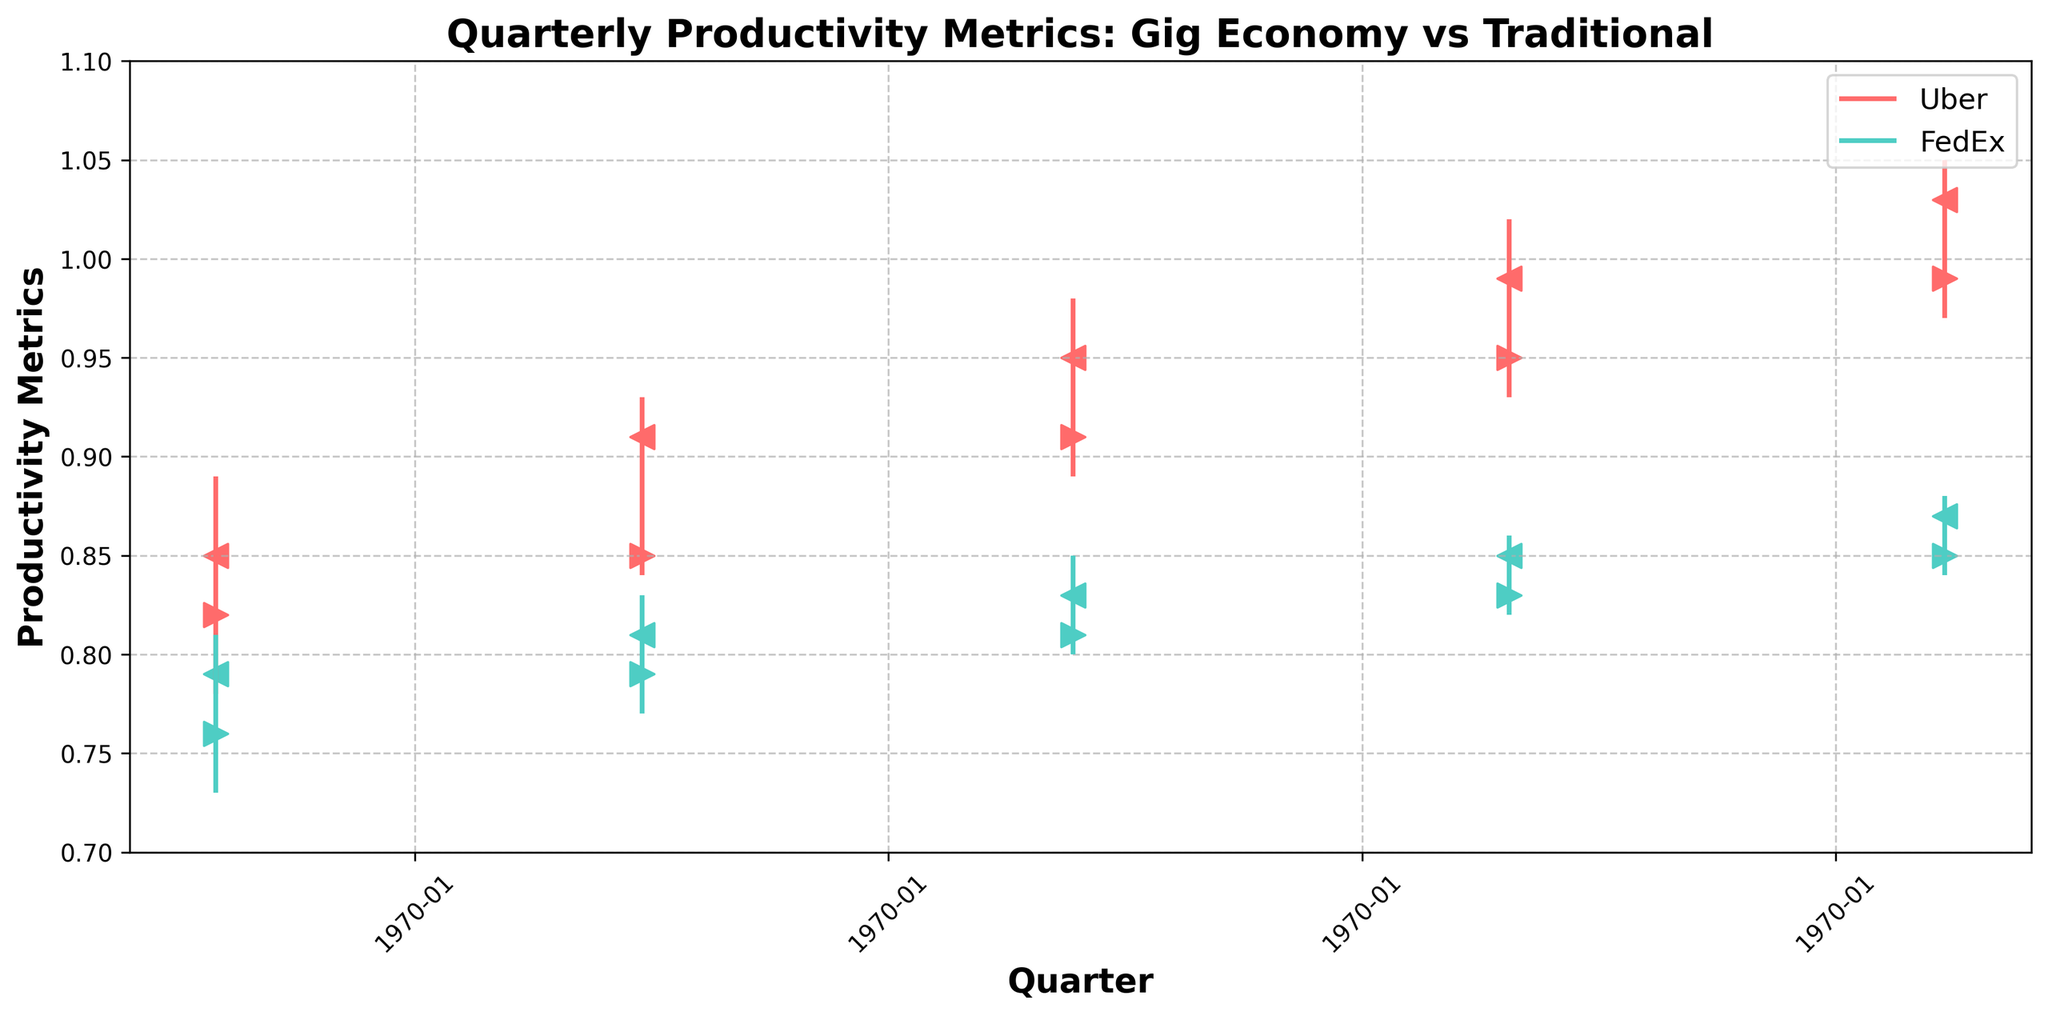What is the title of the chart? The title of the chart is displayed at the top center of the chart. It reads "Quarterly Productivity Metrics: Gig Economy vs Traditional".
Answer: Quarterly Productivity Metrics: Gig Economy vs Traditional How many companies are compared in the chart? The chart uses distinct colors for each company and there are two companies compared, identified in the legend as Uber and FedEx.
Answer: Two What is the highest productivity metric value reached by Uber, and in which quarter does it occur? Uber's highest metric value is represented by the highest vertical line for Uber, which reaches 1.05. This occurs in Q1 2024.
Answer: 1.05 in Q1 2024 Which company has a more substantial increase in the productivity metric from Q1 2023 to Q4 2023? Determine the difference in productivity metrics between Q4 2023 and Q1 2023 for each company. Uber goes from 0.85 (Q1 2023 Close) to 0.99 (Q4 2023 Close), a difference of 0.14. FedEx goes from 0.79 (Q1 2023 Close) to 0.85 (Q4 2023 Close), a difference of 0.06. Uber shows a more substantial increase.
Answer: Uber What is the overall trend in Uber's productivity metrics from Q1 2023 to Q1 2024? Analyze Uber's Close values across each quarter: 0.85 (Q1 2023), 0.91 (Q2 2023), 0.95 (Q3 2023), 0.99 (Q4 2023), 1.03 (Q1 2024). The values consistently increase, indicating an upward trend.
Answer: Upward trend What is the median productivity metric value of FedEx across all quarters? List FedEx's Close values: 0.79, 0.81, 0.83, 0.85, 0.87. Sorting these gives 0.79, 0.81, 0.83, 0.85, 0.87, and the median is the middle value, 0.83.
Answer: 0.83 Which company had greater volatility in productivity metrics in Q4 2023, based on the High-Low spread? Calculate the High-Low spread for both companies in Q4 2023. Uber's spread is 1.02 - 0.93 = 0.09 and FedEx's spread is 0.86 - 0.82 = 0.04. Uber has greater volatility.
Answer: Uber In which quarter did FedEx have the smallest difference between Open and Close values? Look at the Open and Close values for FedEx in each quarter: Q1 2023 (0.76, 0.79), Q2 2023 (0.79, 0.81), Q3 2023 (0.81, 0.83), Q4 2023 (0.83, 0.85), Q1 2024 (0.85, 0.87). The smallest difference is in Q2 2023 (0.81 - 0.79 = 0.02).
Answer: Q2 2023 During which quarter did both Uber and FedEx experience their highest closing productivity metrics? Compare both companies' Close values across all quarters. Uber's highest is 1.03 in Q1 2024, and FedEx's highest is 0.87 also in Q1 2024. Thus, Q1 2024 is the quarter where both companies experienced their highest closing metrics.
Answer: Q1 2024 How does the productivity metric Open value of Uber in Q1 2023 compare to the Open value of FedEx in Q1 2024? Check the Open value of Uber in Q1 2023 (0.82) and compare it to the Open value of FedEx in Q1 2024 (0.85). Uber has a smaller Open value compared to FedEx in these respective quarters.
Answer: Uber's Open value in Q1 2023 is smaller than FedEx's Open value in Q1 2024 